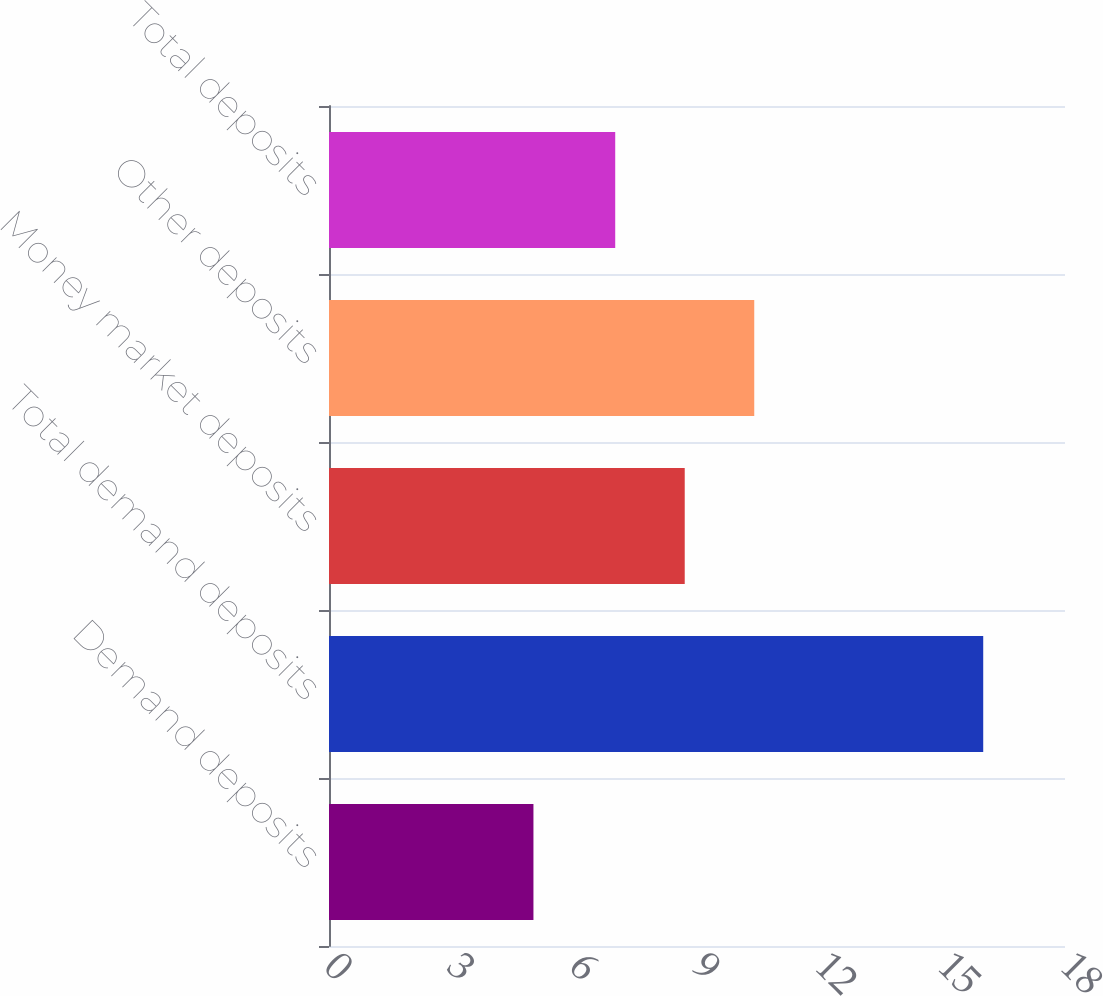<chart> <loc_0><loc_0><loc_500><loc_500><bar_chart><fcel>Demand deposits<fcel>Total demand deposits<fcel>Money market deposits<fcel>Other deposits<fcel>Total deposits<nl><fcel>5<fcel>16<fcel>8.7<fcel>10.4<fcel>7<nl></chart> 